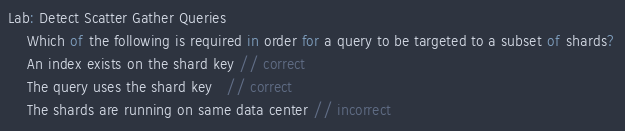Convert code to text. <code><loc_0><loc_0><loc_500><loc_500><_JavaScript_>Lab: Detect Scatter Gather Queries
    Which of the following is required in order for a query to be targeted to a subset of shards?
    An index exists on the shard key // correct  
    The query uses the shard key   // correct 
    The shards are running on same data center // incorrect
</code> 